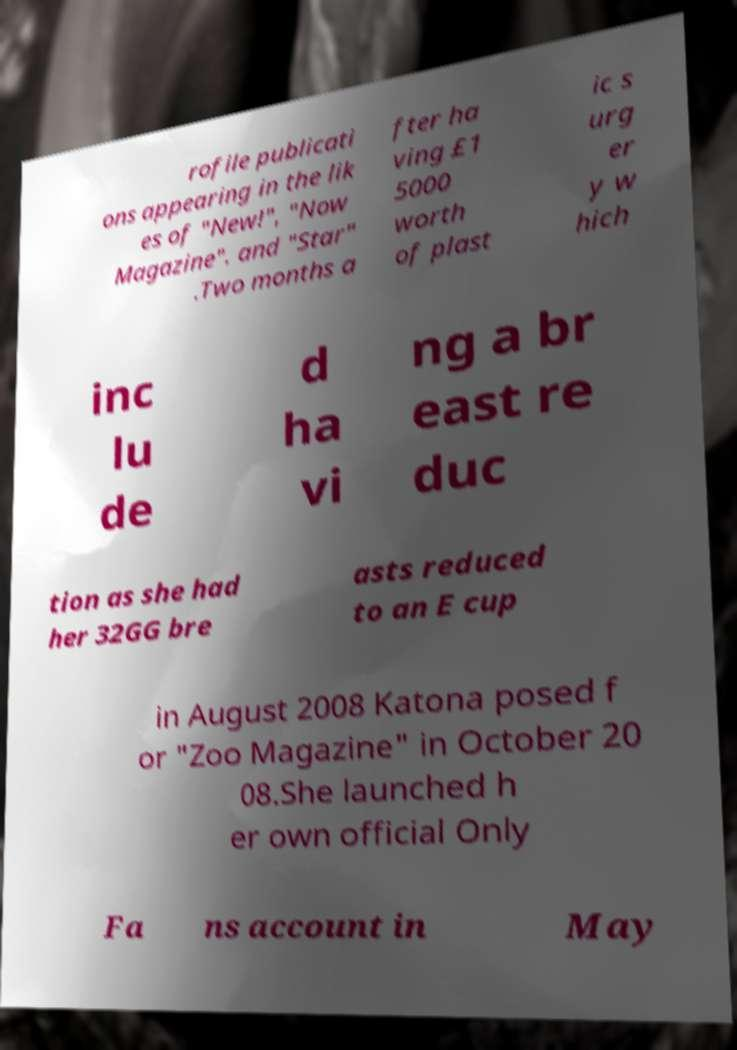Could you assist in decoding the text presented in this image and type it out clearly? rofile publicati ons appearing in the lik es of "New!", "Now Magazine". and "Star" .Two months a fter ha ving £1 5000 worth of plast ic s urg er y w hich inc lu de d ha vi ng a br east re duc tion as she had her 32GG bre asts reduced to an E cup in August 2008 Katona posed f or "Zoo Magazine" in October 20 08.She launched h er own official Only Fa ns account in May 